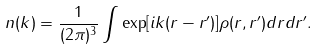Convert formula to latex. <formula><loc_0><loc_0><loc_500><loc_500>n ( { k } ) = \frac { 1 } { ( 2 \pi ) ^ { 3 } } \int \exp [ i { k } ( { r } - { r ^ { \prime } } ) ] \rho ( { r } , { r ^ { \prime } } ) d { r } d { r ^ { \prime } } .</formula> 